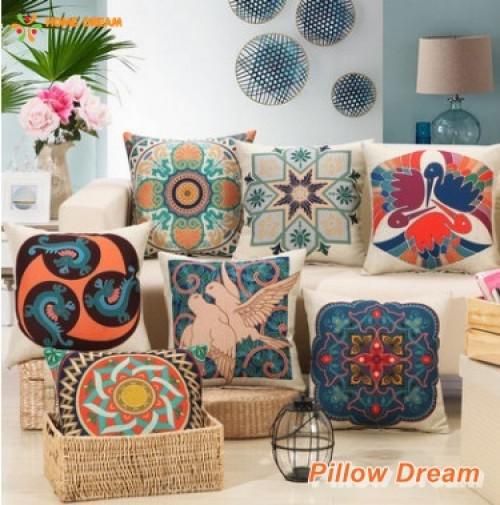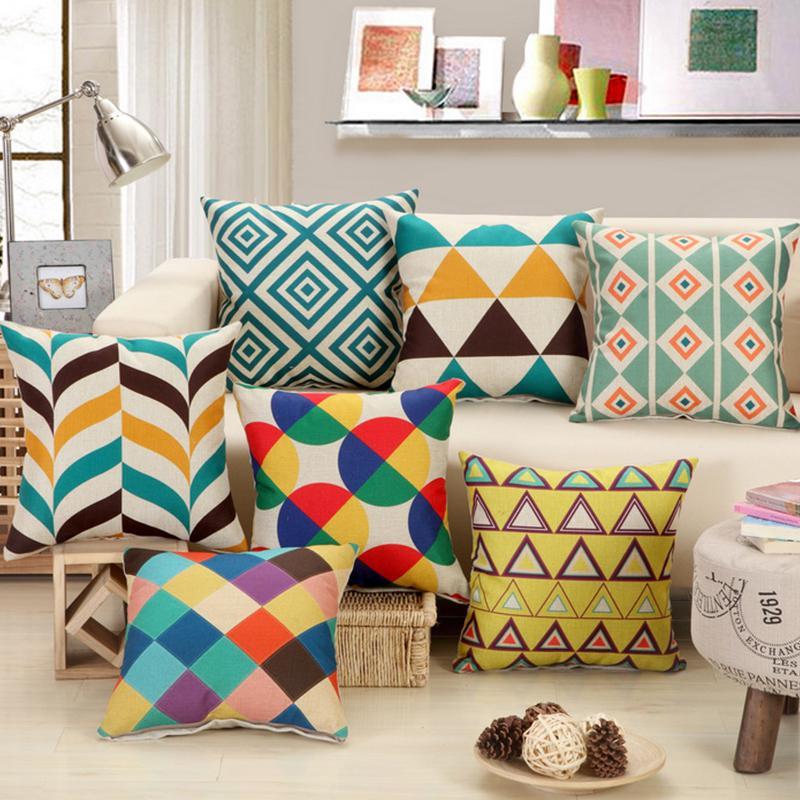The first image is the image on the left, the second image is the image on the right. Evaluate the accuracy of this statement regarding the images: "At least one colorful pillow is displayed in front of a wall featuring round decorative items.". Is it true? Answer yes or no. Yes. 